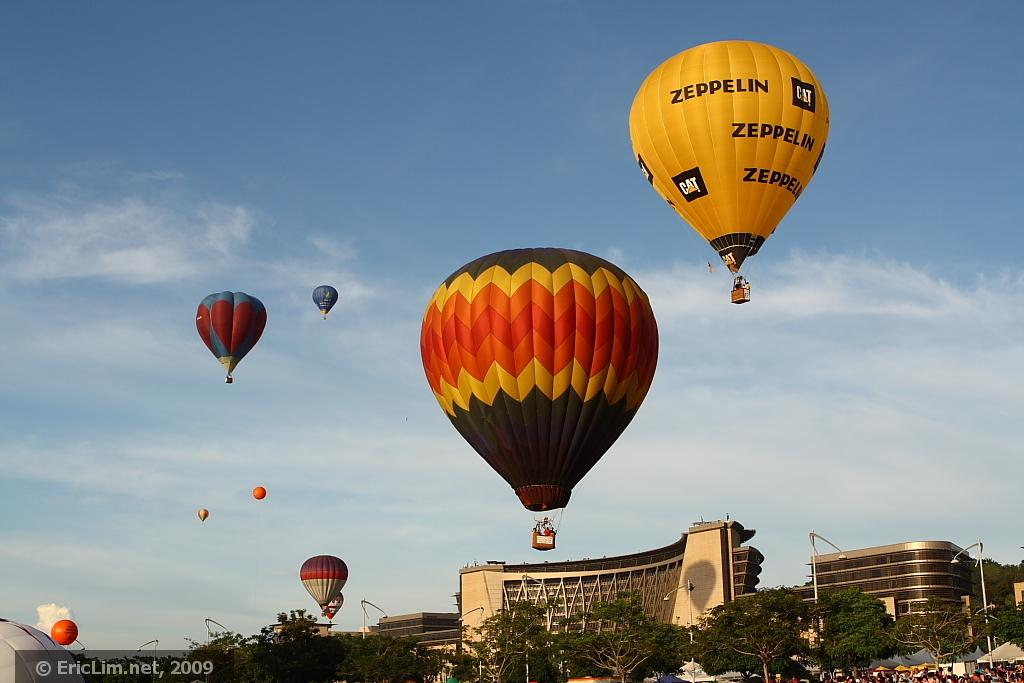<image>
Provide a brief description of the given image. The yellow hot air balloon is sponsored by Zeppelin. 